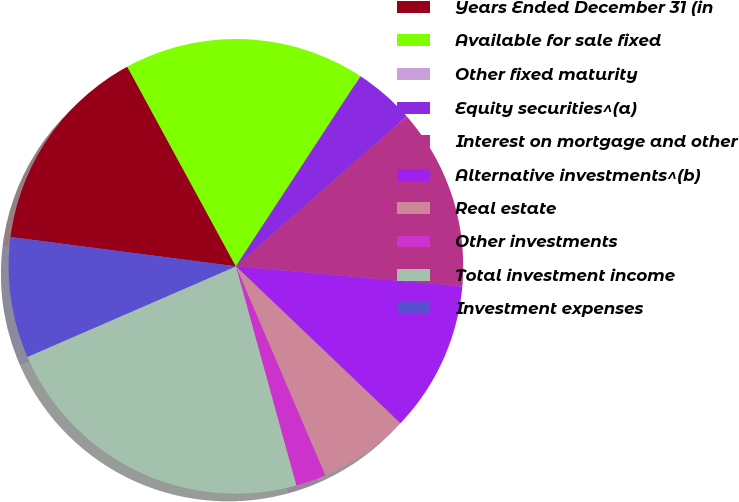Convert chart. <chart><loc_0><loc_0><loc_500><loc_500><pie_chart><fcel>Years Ended December 31 (in<fcel>Available for sale fixed<fcel>Other fixed maturity<fcel>Equity securities^(a)<fcel>Interest on mortgage and other<fcel>Alternative investments^(b)<fcel>Real estate<fcel>Other investments<fcel>Total investment income<fcel>Investment expenses<nl><fcel>15.01%<fcel>17.15%<fcel>0.01%<fcel>4.3%<fcel>12.87%<fcel>10.72%<fcel>6.44%<fcel>2.15%<fcel>22.76%<fcel>8.58%<nl></chart> 